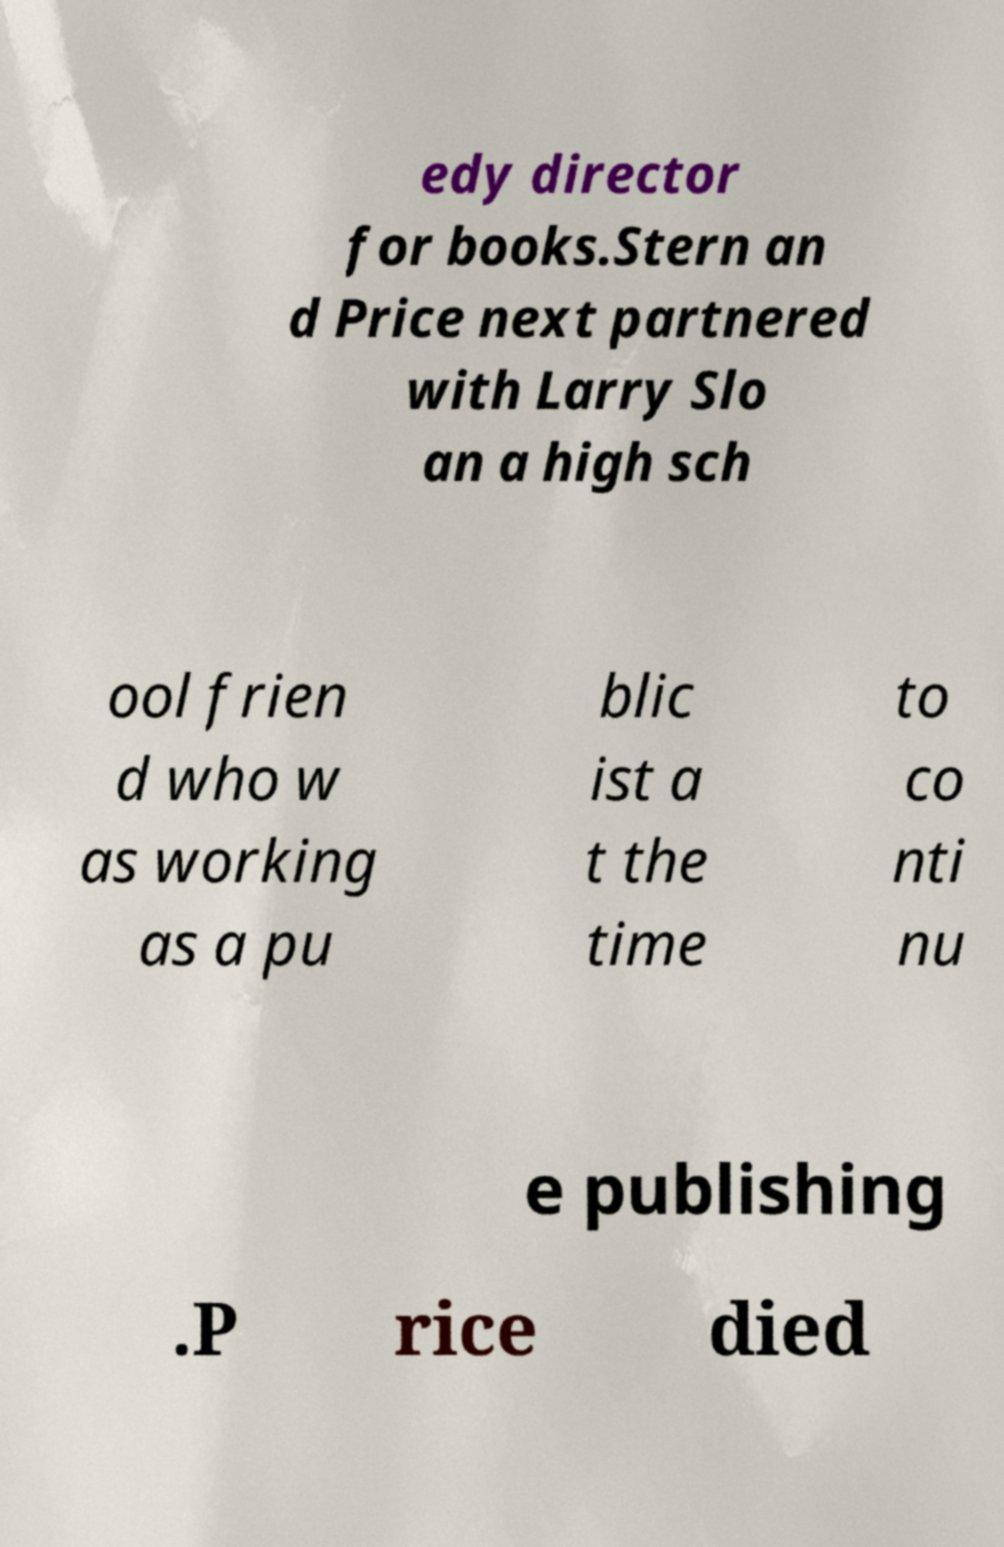Please read and relay the text visible in this image. What does it say? edy director for books.Stern an d Price next partnered with Larry Slo an a high sch ool frien d who w as working as a pu blic ist a t the time to co nti nu e publishing .P rice died 